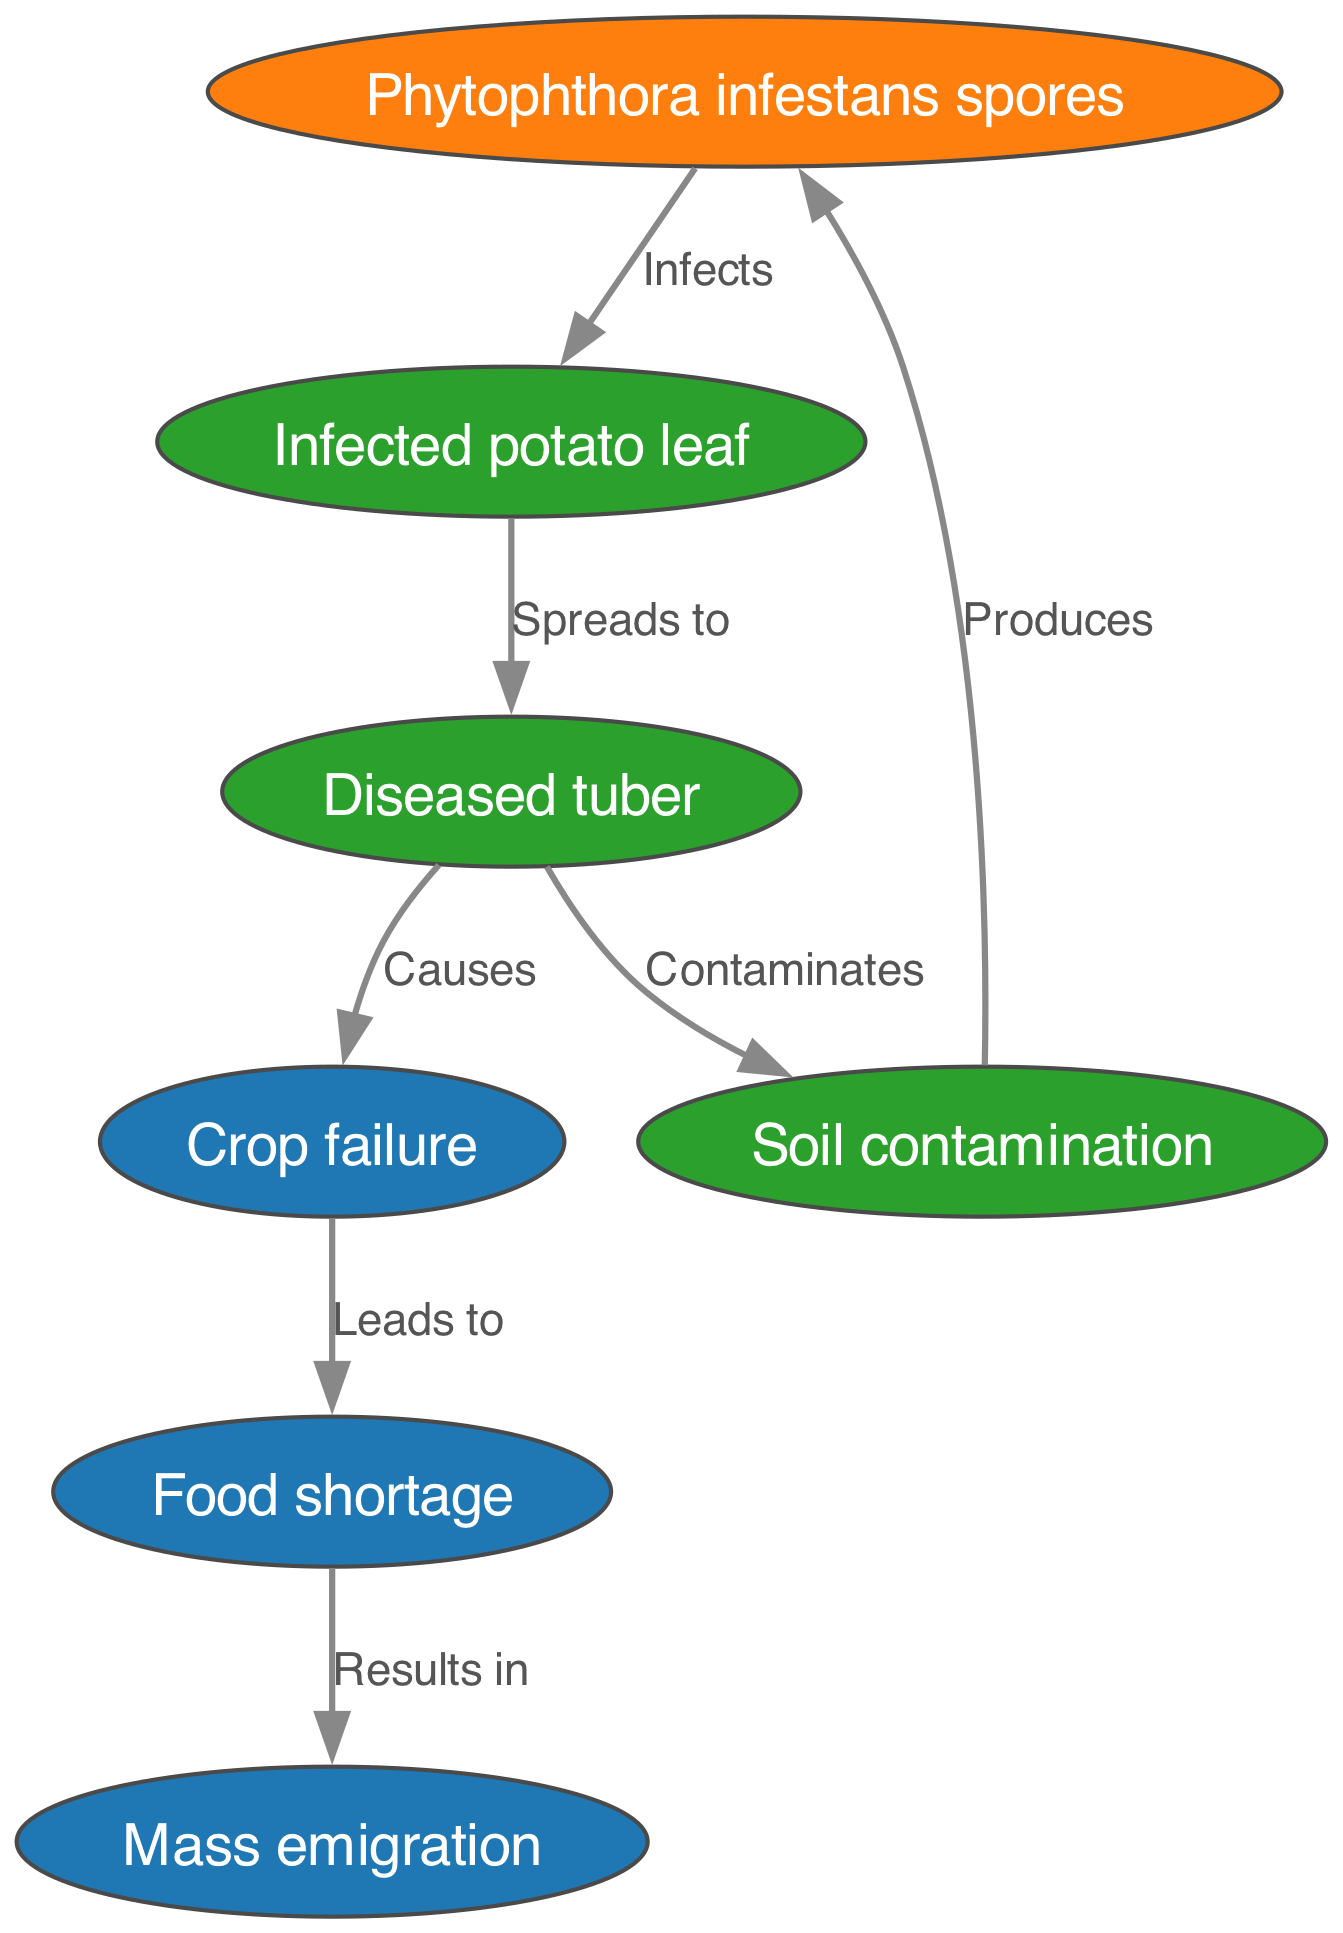What is the first stage in the life cycle of Irish potato blight? According to the diagram, the first stage is the "Phytophthora infestans spores," which serve as the initial point of infection before spreading to the potato leaf.
Answer: Phytophthora infestans spores How many nodes are present in the diagram? The diagram lists seven distinct nodes representing various stages and impacts of Irish potato blight, including spores, infected leaves, diseased tubers, and more.
Answer: Seven What does "Infected potato leaf" spread to? The diagram indicates that the "Infected potato leaf" spreads to "Diseased tuber," which shows a direct relationship in the progression of the blight.
Answer: Diseased tuber What does "Diseased tuber" lead to? The diagram illustrates that a "Diseased tuber" causes "Crop failure," showing a direct consequence of the infection that spreads through the plant lifecycle.
Answer: Crop failure What is the relationship between "Soil contamination" and "Phytophthora infestans spores"? The diagram shows that "Soil contamination" produces "Phytophthora infestans spores," indicating a cyclical nature where contaminated soil contributes to further infection.
Answer: Produces What is the final outcome following a "Food shortage"? The diagram indicates that a "Food shortage" results in "Mass emigration," highlighting the severe socio-economic consequences that can result from agricultural failures in the context of the blight.
Answer: Mass emigration How does "Crop failure" affect food availability? According to the diagram, "Crop failure" leads to "Food shortage," illustrating the direct connection between agricultural output and food supply during the 18th century.
Answer: Food shortage 